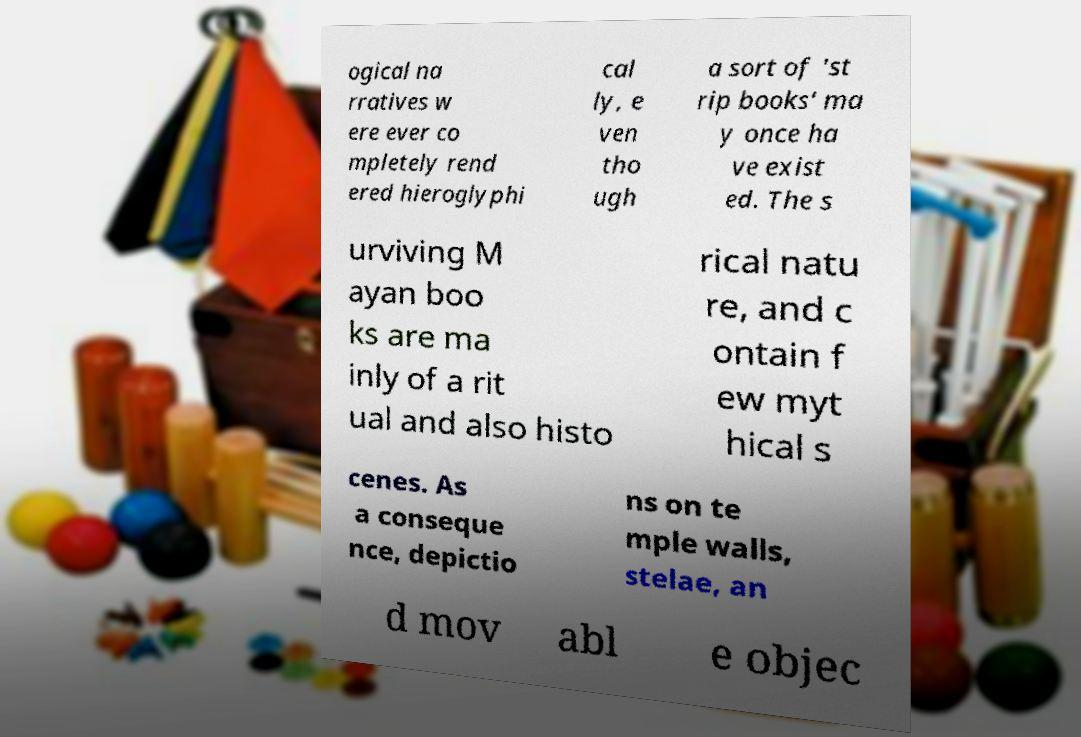For documentation purposes, I need the text within this image transcribed. Could you provide that? ogical na rratives w ere ever co mpletely rend ered hieroglyphi cal ly, e ven tho ugh a sort of 'st rip books' ma y once ha ve exist ed. The s urviving M ayan boo ks are ma inly of a rit ual and also histo rical natu re, and c ontain f ew myt hical s cenes. As a conseque nce, depictio ns on te mple walls, stelae, an d mov abl e objec 